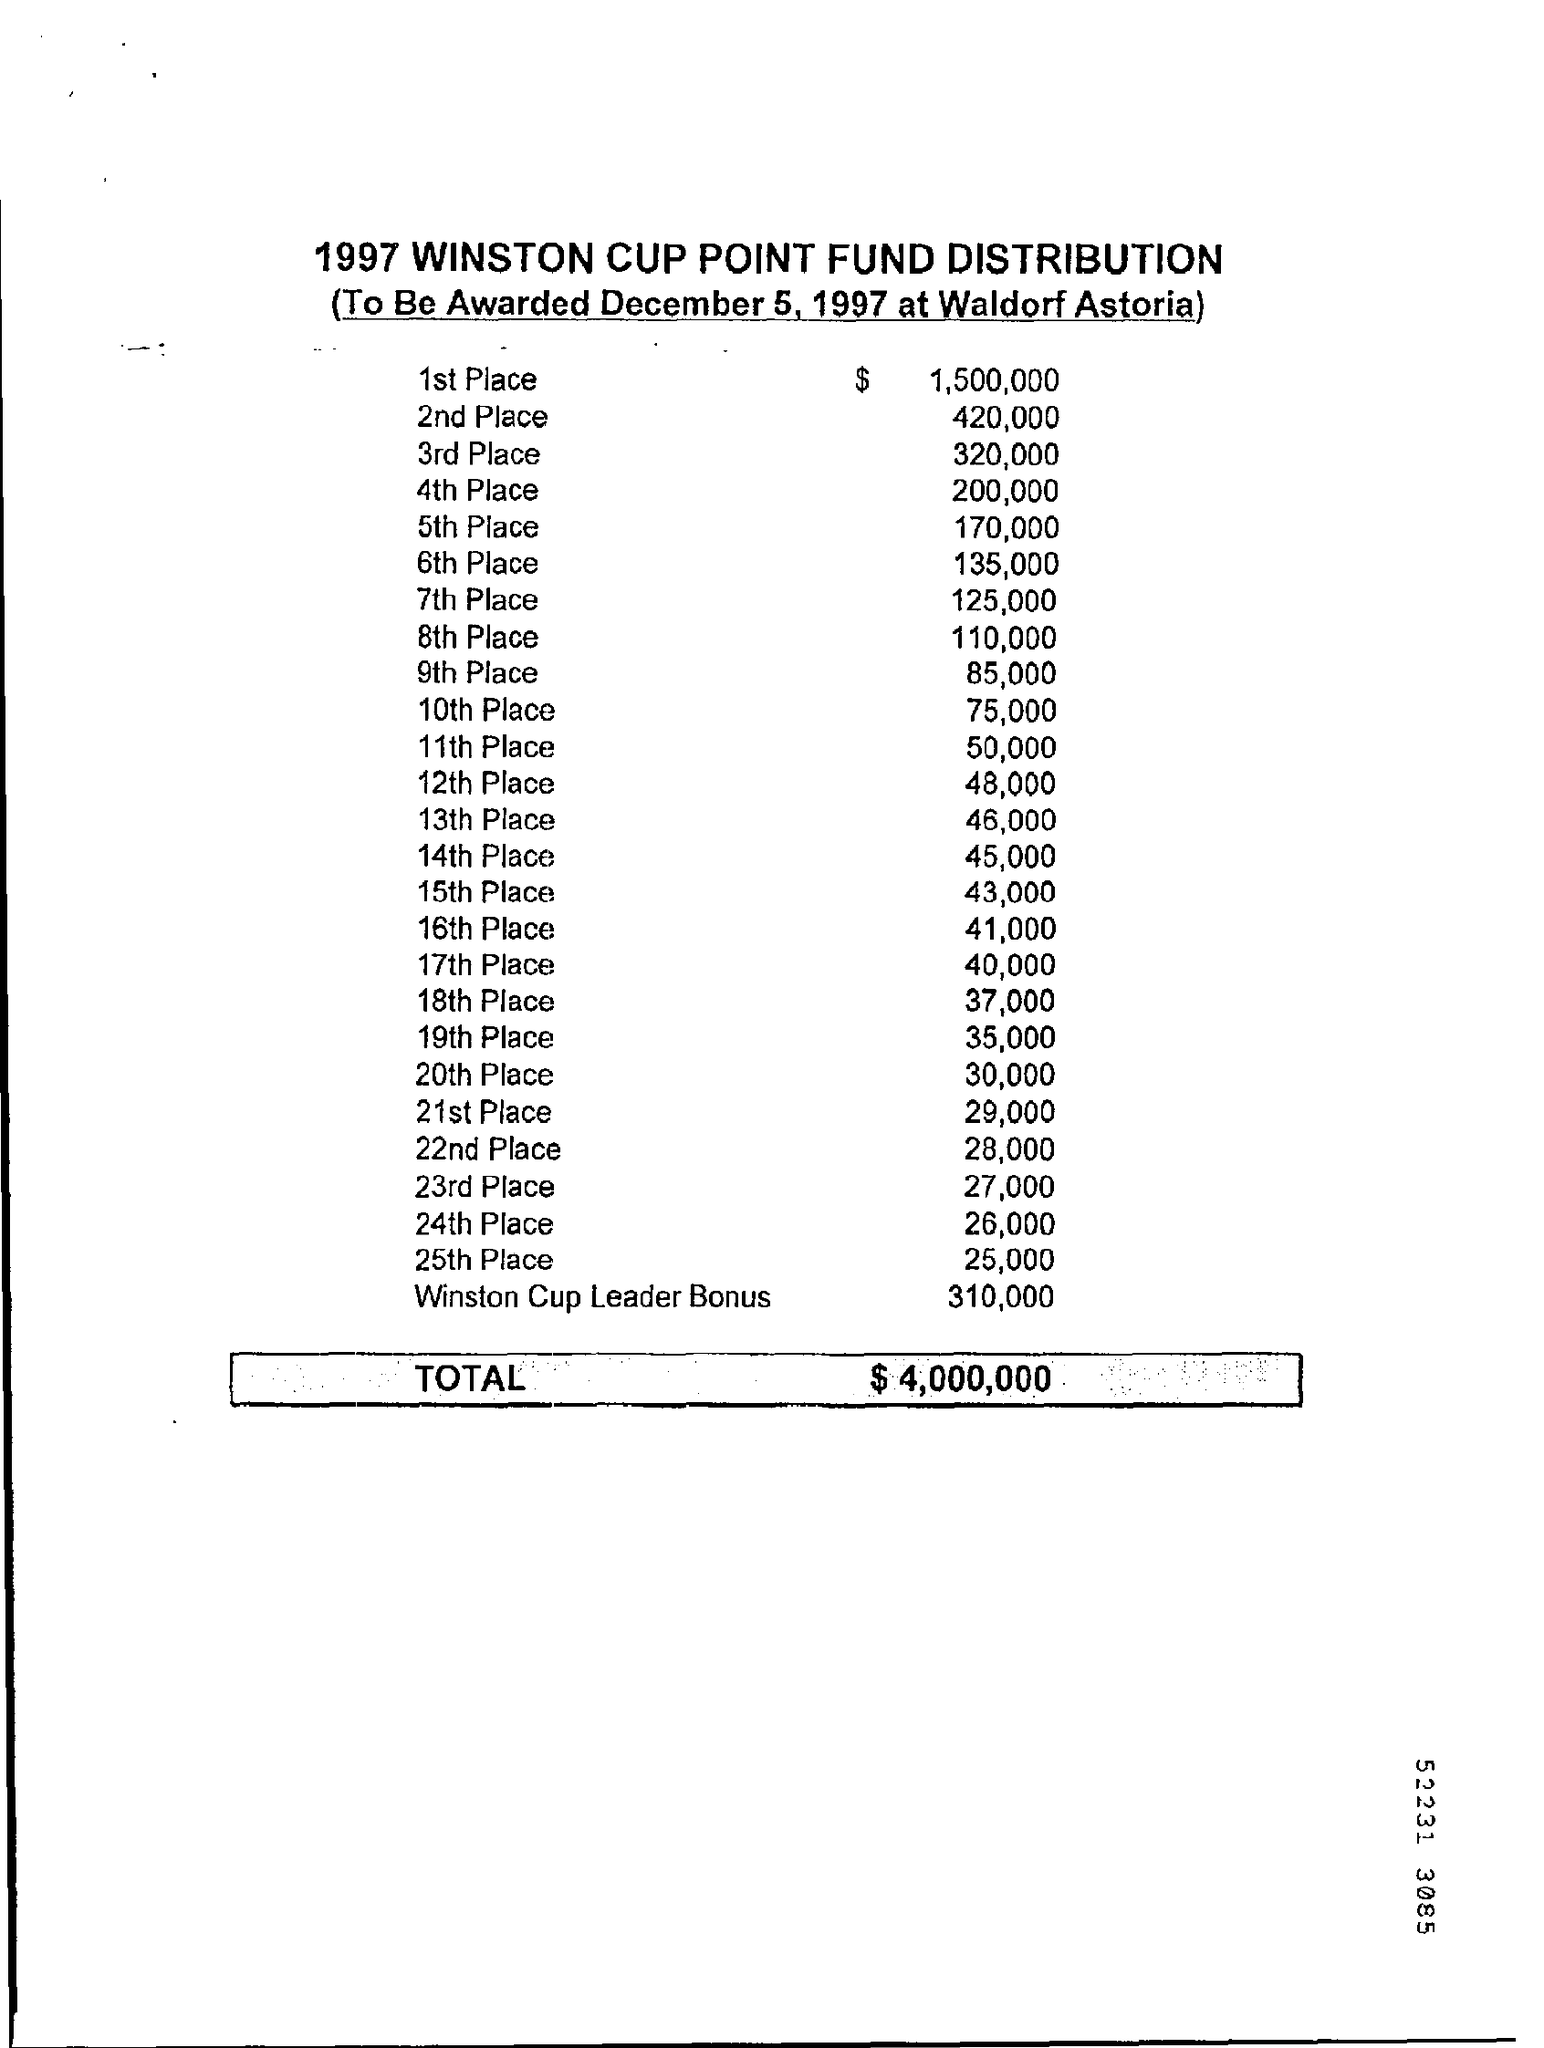How much amount is awarded for the winston cup leader bonus
Provide a succinct answer. $ 310,000. On which date 1997 winston cup point fund distribution is to be awarded ?
Your answer should be very brief. December 5, 1997. 1997 Winston Cup Point fund Distribution is to be awarded at which place ?
Give a very brief answer. Waldorf astoria. How much amount is paid for the 1st place ?
Keep it short and to the point. $ 1,500,000. How much amount is paid for the 21st place ?
Keep it short and to the point. 29,000. What is the total amount for the 1997 winston cup point fund distribution ?
Keep it short and to the point. $4,000,000. How much amount is paid for the 5th place ?
Ensure brevity in your answer.  170,000. How much amount is paid for the 11th place ?
Provide a succinct answer. $ 50,000. How much amount is paid for the 19th place ?
Provide a short and direct response. $ 35,000. How much amount is paid for the 24th place ?
Your answer should be compact. $ 26,000. 